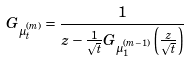Convert formula to latex. <formula><loc_0><loc_0><loc_500><loc_500>G _ { \mu _ { t } ^ { ( m ) } } = \frac { 1 } { z - \frac { 1 } { \sqrt { t } } G _ { \mu _ { 1 } ^ { ( m - 1 ) } } \left ( \frac { z } { \sqrt { t } } \right ) }</formula> 